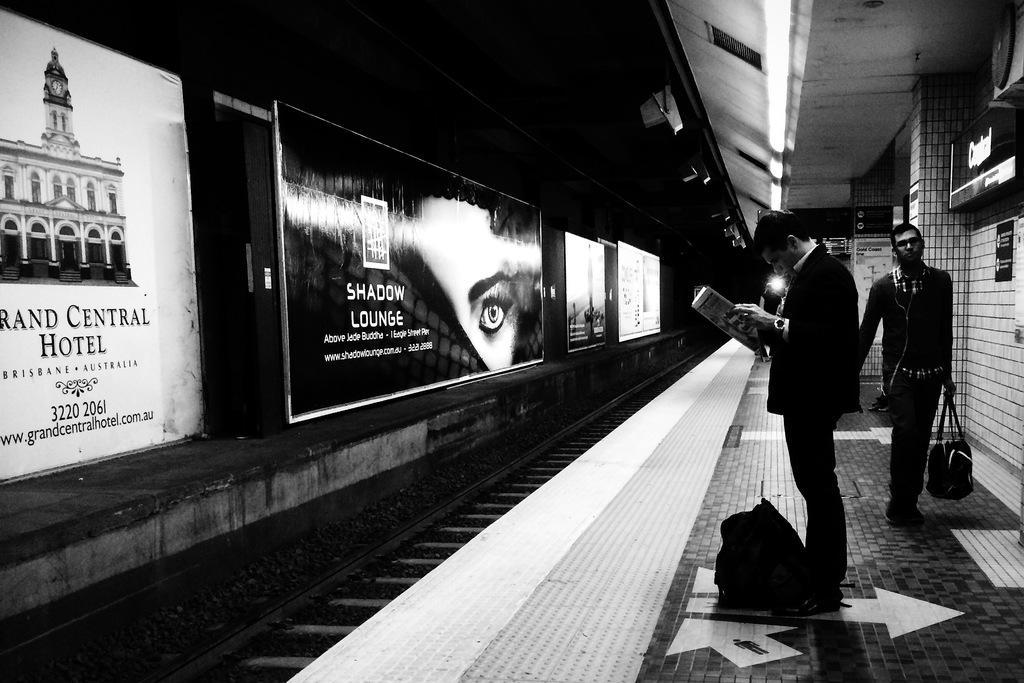How would you summarize this image in a sentence or two? This is a black and white picture. In this picture we can see the boards, screen, people, objects, bags, railway track and platform. We can see a person is holding a magazine and reading. We can see a man is holding a bag. 